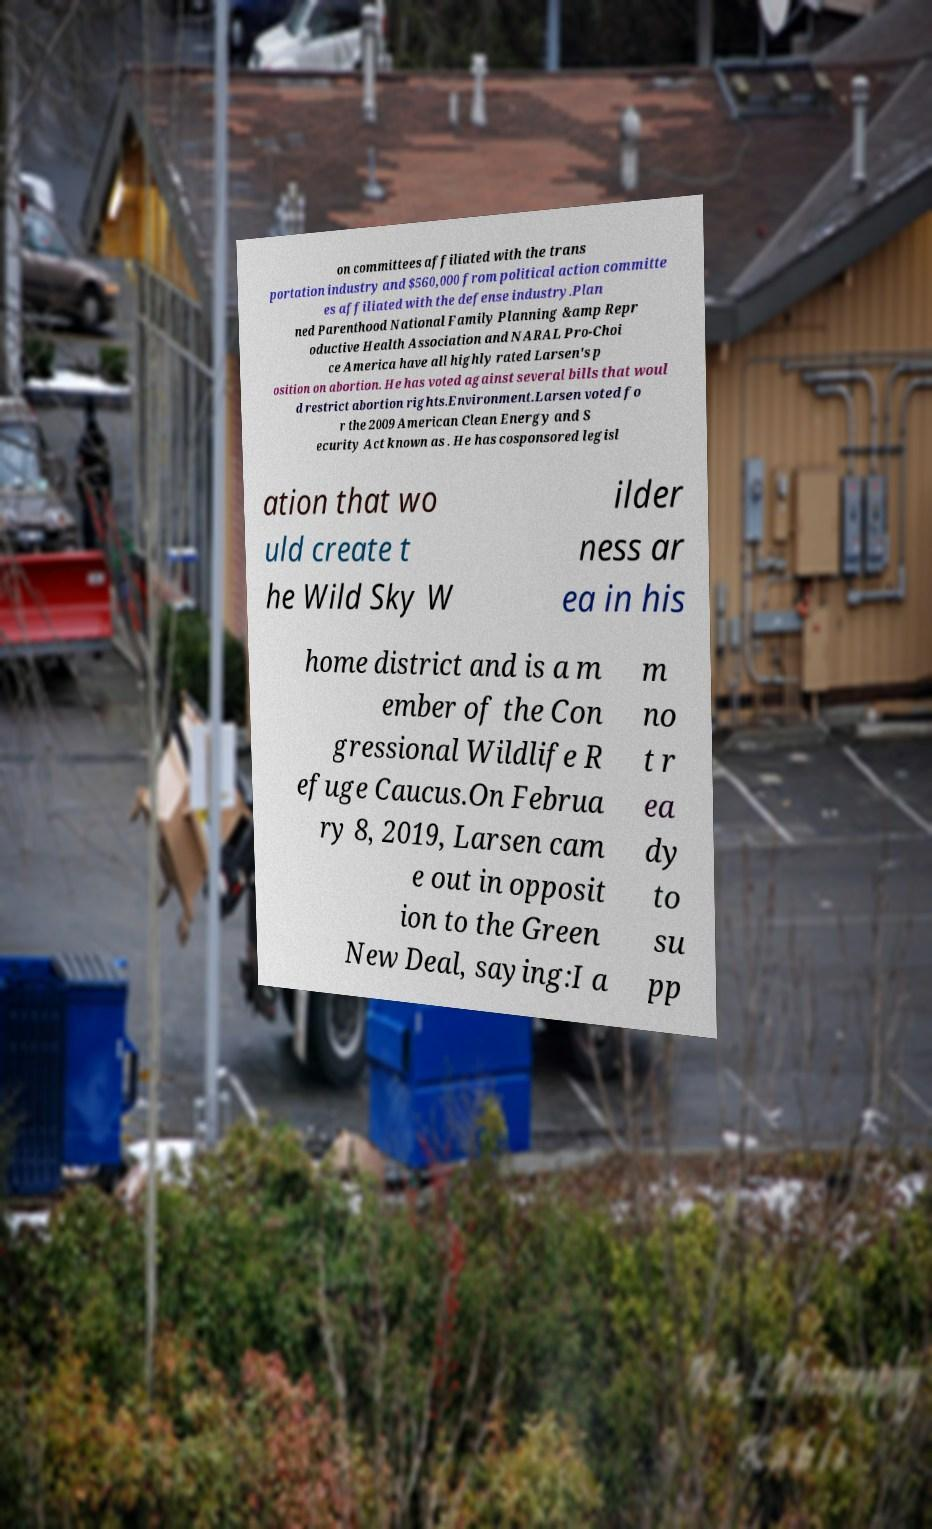Could you extract and type out the text from this image? on committees affiliated with the trans portation industry and $560,000 from political action committe es affiliated with the defense industry.Plan ned Parenthood National Family Planning &amp Repr oductive Health Association and NARAL Pro-Choi ce America have all highly rated Larsen's p osition on abortion. He has voted against several bills that woul d restrict abortion rights.Environment.Larsen voted fo r the 2009 American Clean Energy and S ecurity Act known as . He has cosponsored legisl ation that wo uld create t he Wild Sky W ilder ness ar ea in his home district and is a m ember of the Con gressional Wildlife R efuge Caucus.On Februa ry 8, 2019, Larsen cam e out in opposit ion to the Green New Deal, saying:I a m no t r ea dy to su pp 